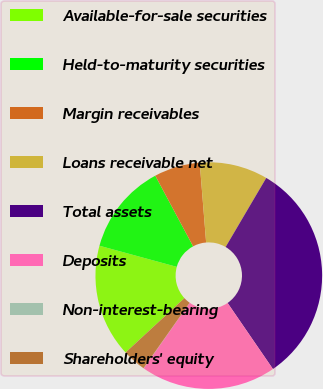Convert chart to OTSL. <chart><loc_0><loc_0><loc_500><loc_500><pie_chart><fcel>Available-for-sale securities<fcel>Held-to-maturity securities<fcel>Margin receivables<fcel>Loans receivable net<fcel>Total assets<fcel>Deposits<fcel>Non-interest-bearing<fcel>Shareholders' equity<nl><fcel>16.12%<fcel>12.93%<fcel>6.55%<fcel>9.74%<fcel>31.96%<fcel>19.32%<fcel>0.03%<fcel>3.35%<nl></chart> 